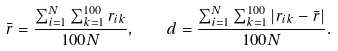Convert formula to latex. <formula><loc_0><loc_0><loc_500><loc_500>\bar { r } = \frac { \sum _ { i = 1 } ^ { N } \sum _ { k = 1 } ^ { 1 0 0 } r _ { i k } } { 1 0 0 N } , \quad d = \frac { \sum _ { i = 1 } ^ { N } \sum _ { k = 1 } ^ { 1 0 0 } | r _ { i k } - \bar { r } | } { 1 0 0 N } .</formula> 